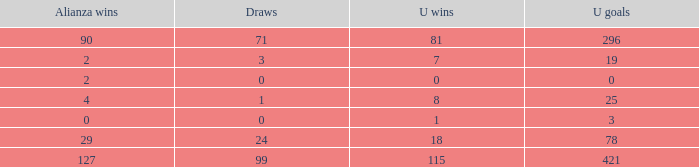What is the lowest Draws, when Alianza Goals is less than 317, when U Goals is less than 3, and when Alianza Wins is less than 2? None. 